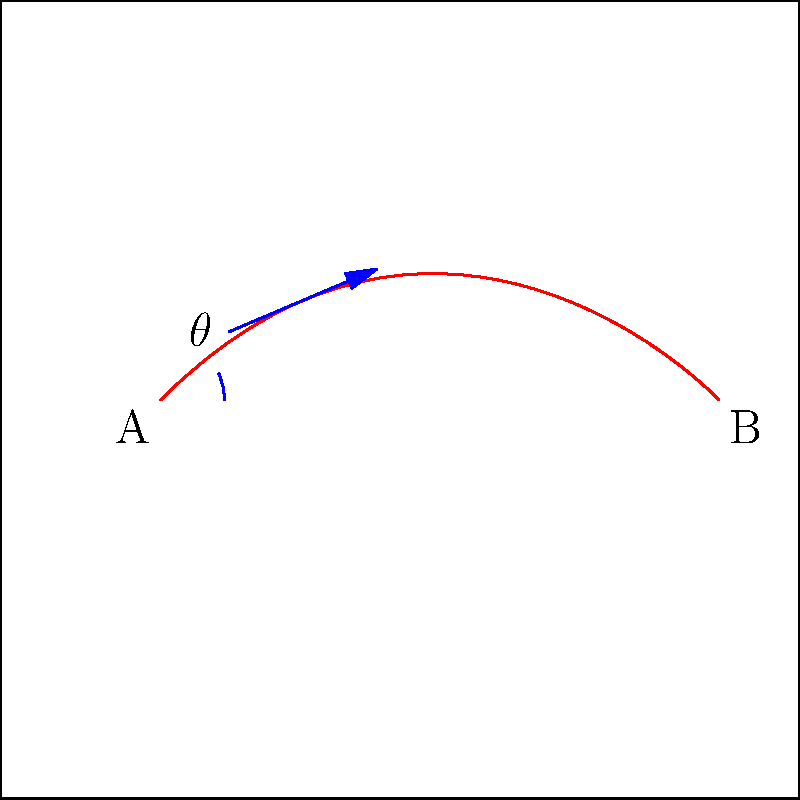In a crucial free kick scenario, you need to curve the ball around the defensive wall to score. Given that the ball starts at point A and needs to reach point B, calculate the optimal initial angle $\theta$ for the kick using principles of differential topology. Assume the ball's path can be modeled as a smooth curve, and the optimal angle maximizes the curvature at the start of the trajectory. To find the optimal initial angle $\theta$ for the curved free kick, we'll use principles of differential topology:

1) The ball's path can be modeled as a smooth curve $\gamma(t) = (x(t), y(t))$ where $t \in [0,1]$.

2) The curvature $\kappa$ of a curve in 2D is given by:

   $$\kappa = \frac{|x'y'' - y'x''|}{(x'^2 + y'^2)^{3/2}}$$

3) At $t=0$ (the start of the kick), we want to maximize this curvature. The initial angle $\theta$ determines the initial velocity vector $(x'(0), y'(0)) = (\cos\theta, \sin\theta)$.

4) Assuming a quadratic approximation for the curve near the start:
   
   $$x(t) \approx t\cos\theta + at^2, \quad y(t) \approx t\sin\theta + bt^2$$

   where $a$ and $b$ are constants determining the curve's shape.

5) Substituting into the curvature formula at $t=0$:

   $$\kappa(0) = \frac{|2(b\cos\theta - a\sin\theta)|}{1^{3/2}} = 2|b\cos\theta - a\sin\theta|$$

6) To maximize this, we need:

   $$\frac{d}{d\theta}(2|b\cos\theta - a\sin\theta|) = 0$$

7) Solving this equation leads to:

   $$\tan\theta = \frac{b}{a}$$

8) The optimal angle is therefore:

   $$\theta = \arctan(\frac{b}{a})$$

9) The ratio $b/a$ depends on the specific curve needed to reach point B, which would be determined by the position of the defensive wall and other factors on the field.
Answer: $\theta = \arctan(\frac{b}{a})$, where $b/a$ is the ratio of vertical to horizontal quadratic coefficients in the ball's trajectory. 